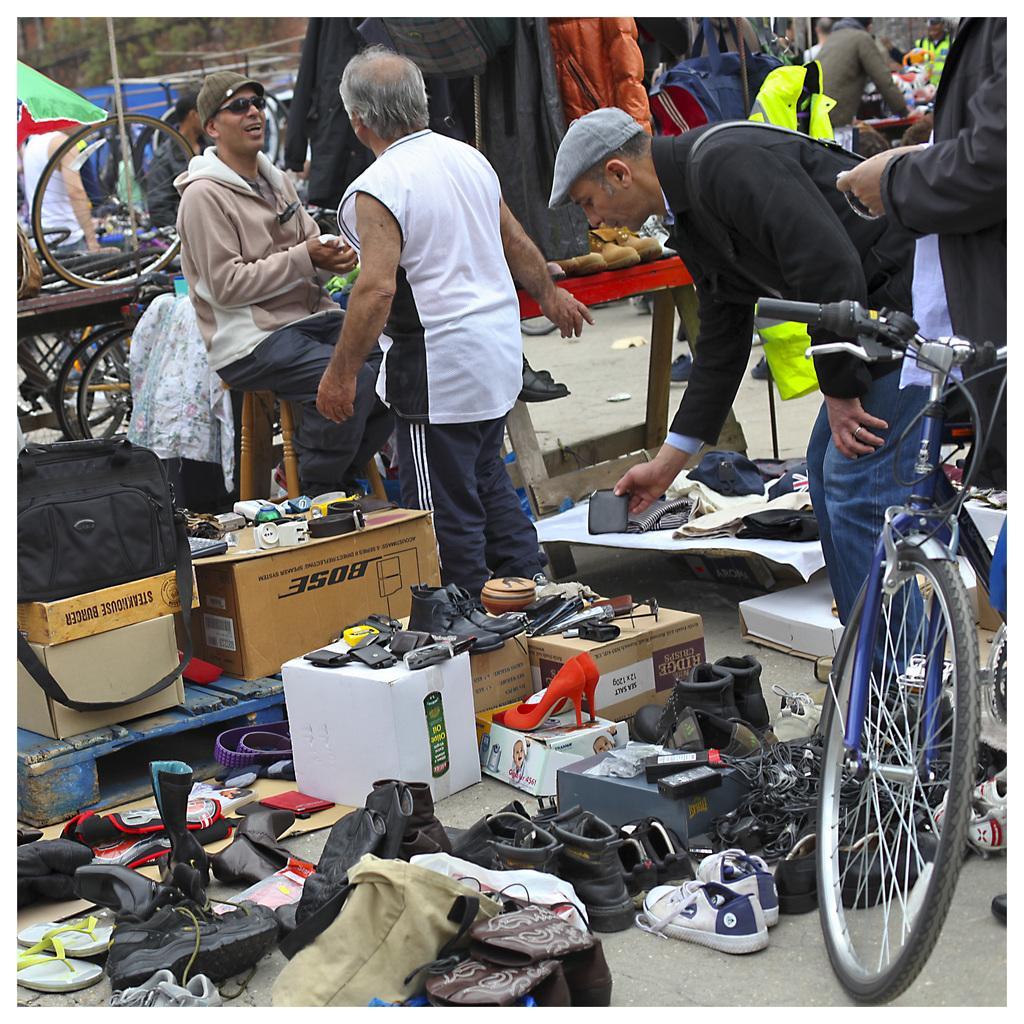How would you summarize this image in a sentence or two? This is a picture taken in a outdoor, There are group of people on the road. There is a man in white t shirt standing on the road in front of the man there is a shoes and sandals and wooden cardboard boxes and there is a bicycle. Background of this people is a black cover and a wheel. 